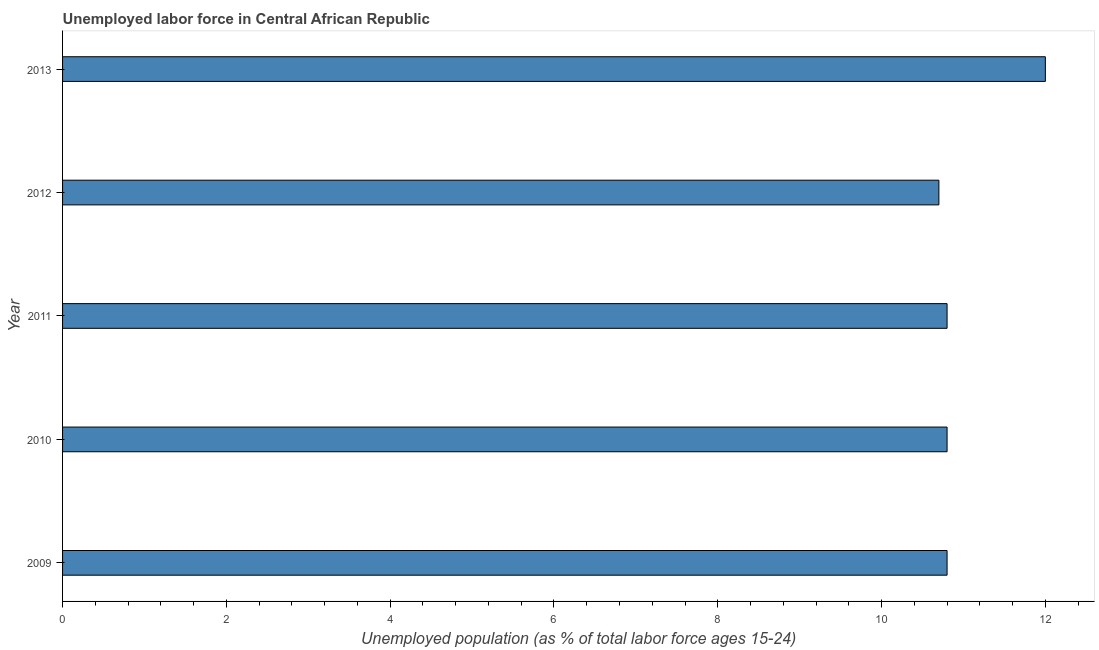Does the graph contain any zero values?
Provide a succinct answer. No. What is the title of the graph?
Ensure brevity in your answer.  Unemployed labor force in Central African Republic. What is the label or title of the X-axis?
Keep it short and to the point. Unemployed population (as % of total labor force ages 15-24). What is the label or title of the Y-axis?
Offer a terse response. Year. Across all years, what is the maximum total unemployed youth population?
Your response must be concise. 12. Across all years, what is the minimum total unemployed youth population?
Keep it short and to the point. 10.7. In which year was the total unemployed youth population minimum?
Offer a terse response. 2012. What is the sum of the total unemployed youth population?
Provide a short and direct response. 55.1. What is the difference between the total unemployed youth population in 2010 and 2013?
Ensure brevity in your answer.  -1.2. What is the average total unemployed youth population per year?
Offer a very short reply. 11.02. What is the median total unemployed youth population?
Offer a very short reply. 10.8. What is the ratio of the total unemployed youth population in 2010 to that in 2012?
Ensure brevity in your answer.  1.01. Is the difference between the total unemployed youth population in 2009 and 2013 greater than the difference between any two years?
Keep it short and to the point. No. What is the difference between the highest and the second highest total unemployed youth population?
Offer a terse response. 1.2. What is the difference between the highest and the lowest total unemployed youth population?
Your answer should be very brief. 1.3. How many bars are there?
Ensure brevity in your answer.  5. How many years are there in the graph?
Keep it short and to the point. 5. What is the Unemployed population (as % of total labor force ages 15-24) of 2009?
Your answer should be very brief. 10.8. What is the Unemployed population (as % of total labor force ages 15-24) in 2010?
Your response must be concise. 10.8. What is the Unemployed population (as % of total labor force ages 15-24) in 2011?
Keep it short and to the point. 10.8. What is the Unemployed population (as % of total labor force ages 15-24) in 2012?
Provide a succinct answer. 10.7. What is the difference between the Unemployed population (as % of total labor force ages 15-24) in 2009 and 2013?
Your answer should be very brief. -1.2. What is the difference between the Unemployed population (as % of total labor force ages 15-24) in 2011 and 2013?
Give a very brief answer. -1.2. What is the difference between the Unemployed population (as % of total labor force ages 15-24) in 2012 and 2013?
Offer a very short reply. -1.3. What is the ratio of the Unemployed population (as % of total labor force ages 15-24) in 2009 to that in 2010?
Offer a terse response. 1. What is the ratio of the Unemployed population (as % of total labor force ages 15-24) in 2010 to that in 2011?
Your answer should be compact. 1. What is the ratio of the Unemployed population (as % of total labor force ages 15-24) in 2010 to that in 2012?
Make the answer very short. 1.01. What is the ratio of the Unemployed population (as % of total labor force ages 15-24) in 2011 to that in 2012?
Keep it short and to the point. 1.01. What is the ratio of the Unemployed population (as % of total labor force ages 15-24) in 2011 to that in 2013?
Make the answer very short. 0.9. What is the ratio of the Unemployed population (as % of total labor force ages 15-24) in 2012 to that in 2013?
Give a very brief answer. 0.89. 